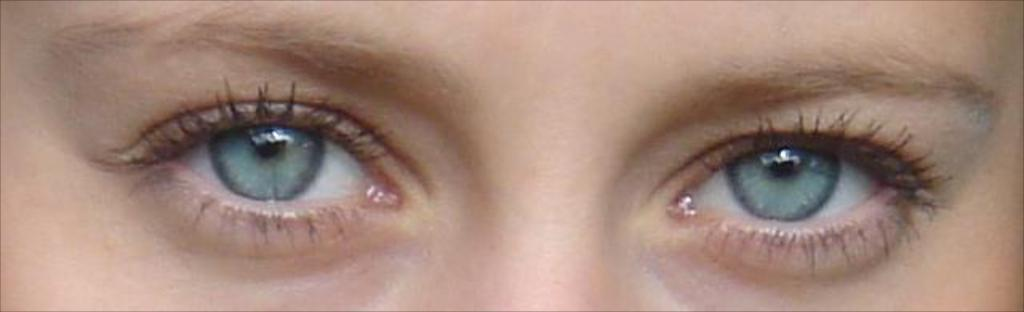What is the main subject of the image? The main subject of the image is the eyes of a person. Can you describe the eyes in the image? Unfortunately, the facts provided do not give any details about the appearance of the eyes. What might the person be looking at or thinking about? The facts provided do not give any information about the person's focus or thoughts. What type of weather can be seen in the image? There is no weather present in the image, as it only features the eyes of a person. Can you tell me how many mittens are visible in the image? There are no mittens present in the image; it only features the eyes of a person. 